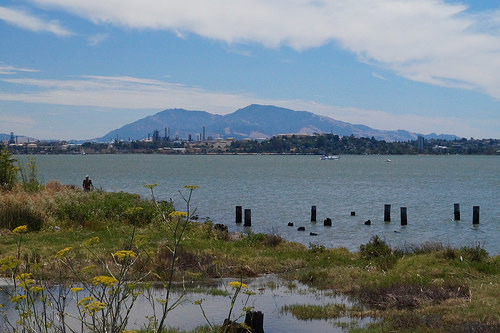<image>
Is there a dock in front of the mountain? Yes. The dock is positioned in front of the mountain, appearing closer to the camera viewpoint. 